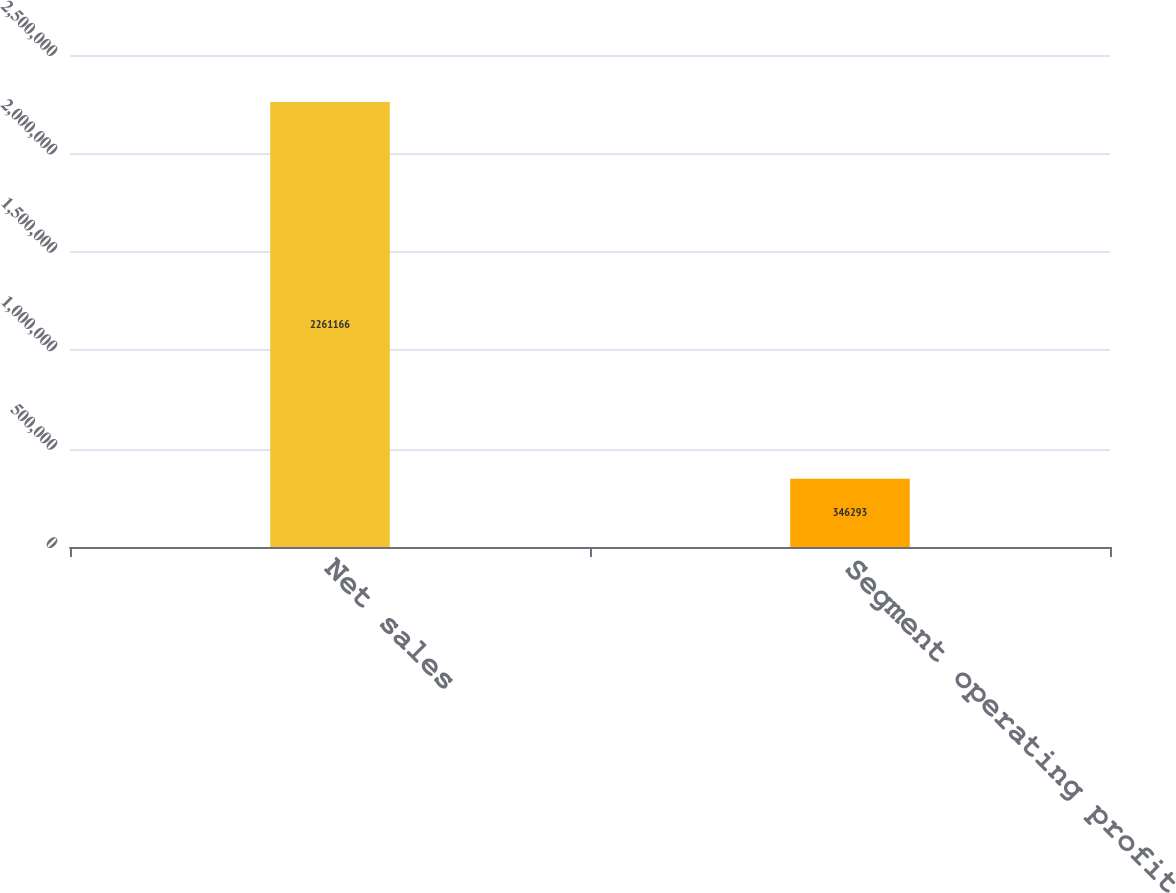Convert chart to OTSL. <chart><loc_0><loc_0><loc_500><loc_500><bar_chart><fcel>Net sales<fcel>Segment operating profit<nl><fcel>2.26117e+06<fcel>346293<nl></chart> 